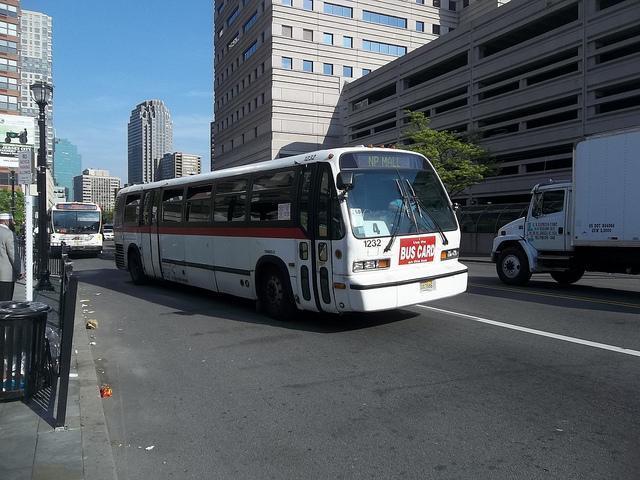How many buses?
Give a very brief answer. 2. How many buses are there?
Give a very brief answer. 2. 